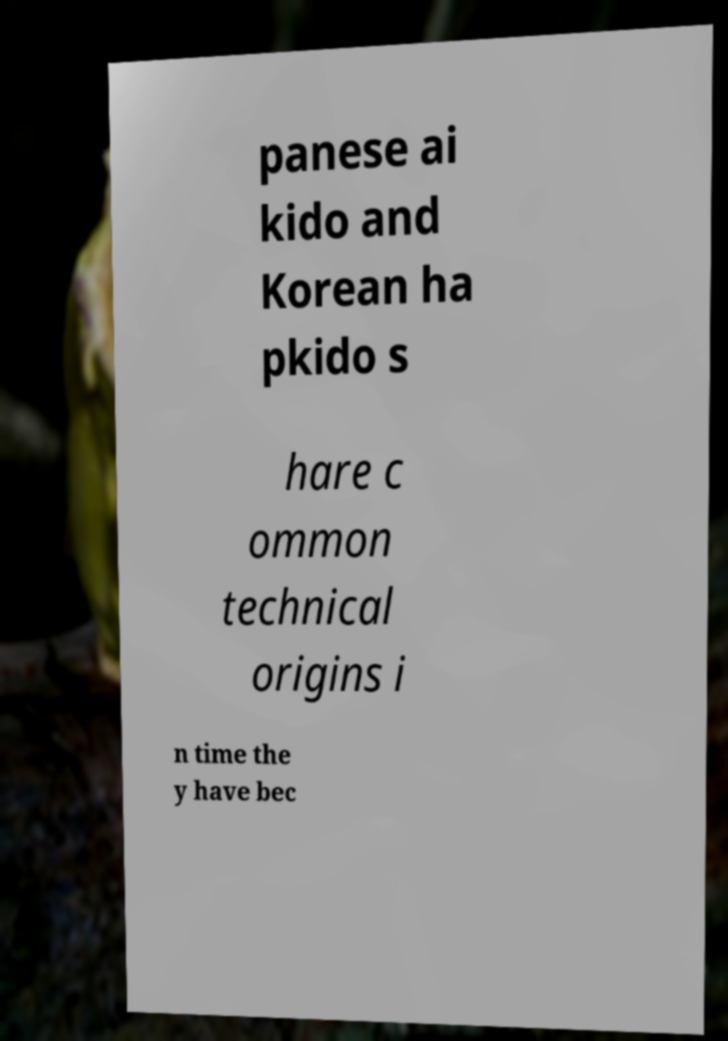Please read and relay the text visible in this image. What does it say? panese ai kido and Korean ha pkido s hare c ommon technical origins i n time the y have bec 